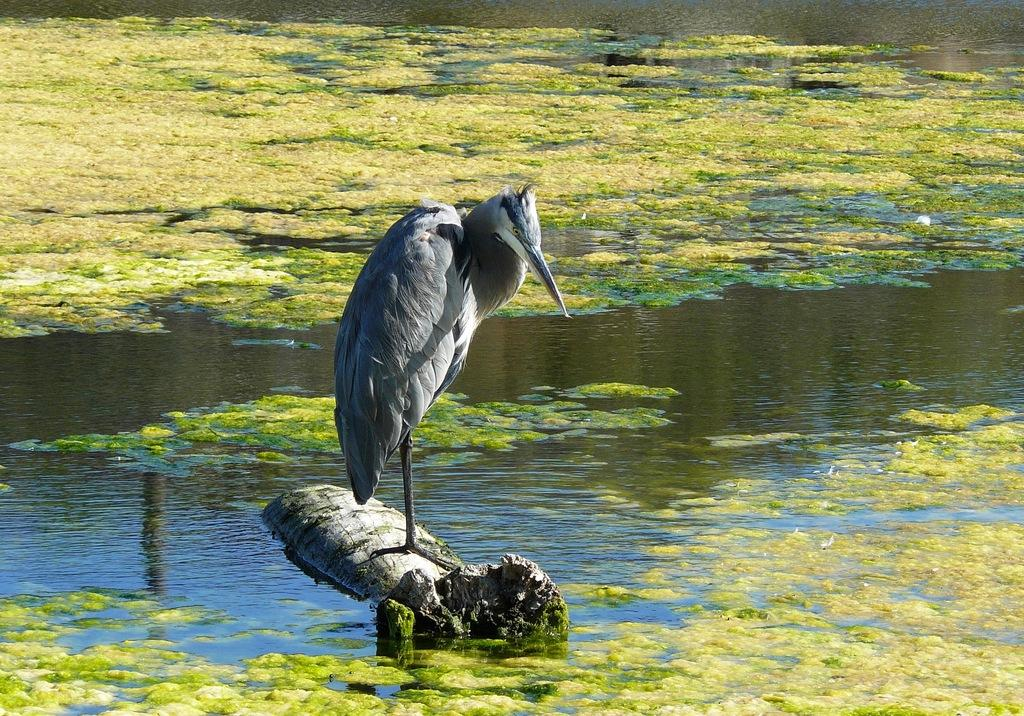What type of animal can be seen in the image? There is a bird in the image. Where is the bird located? The bird is on a log. What can be seen in the background of the image? There is water visible in the background of the image. How does the bird experience loss in the image? There is no indication of loss in the image; it simply shows a bird on a log with water in the background. 